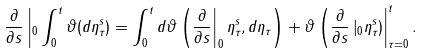Convert formula to latex. <formula><loc_0><loc_0><loc_500><loc_500>\frac { \partial } { \partial s } \left | _ { 0 } \int _ { 0 } ^ { t } \vartheta ( d \eta _ { \tau } ^ { s } ) = \int _ { 0 } ^ { t } d \vartheta \left ( \frac { \partial } { \partial s } \right | _ { 0 } \eta _ { \tau } ^ { s } , d \eta _ { \tau } \right ) + \vartheta \left ( \frac { \partial } { \partial s } \left | _ { 0 } \eta _ { \tau } ^ { s } \right ) \right | _ { \tau = 0 } ^ { t } .</formula> 